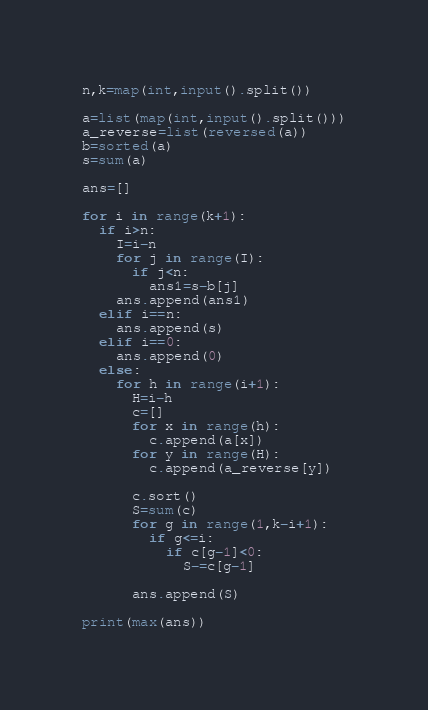Convert code to text. <code><loc_0><loc_0><loc_500><loc_500><_Python_>n,k=map(int,input().split())

a=list(map(int,input().split()))
a_reverse=list(reversed(a))
b=sorted(a)
s=sum(a)

ans=[]

for i in range(k+1):
  if i>n:
    I=i-n
    for j in range(I): 
      if j<n:
        ans1=s-b[j]
    ans.append(ans1)
  elif i==n:
    ans.append(s)
  elif i==0:
    ans.append(0)
  else:
    for h in range(i+1):
      H=i-h
      c=[]
      for x in range(h):
        c.append(a[x])
      for y in range(H):
        c.append(a_reverse[y])
        
      c.sort()
      S=sum(c)
      for g in range(1,k-i+1):
        if g<=i:
          if c[g-1]<0:
            S-=c[g-1]

      ans.append(S)
      
print(max(ans))</code> 